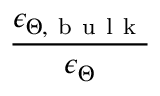Convert formula to latex. <formula><loc_0><loc_0><loc_500><loc_500>\frac { \epsilon _ { \Theta , b u l k } } { \epsilon _ { \Theta } }</formula> 